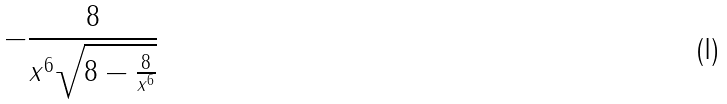<formula> <loc_0><loc_0><loc_500><loc_500>- \frac { 8 } { x ^ { 6 } \sqrt { 8 - \frac { 8 } { x ^ { 6 } } } }</formula> 